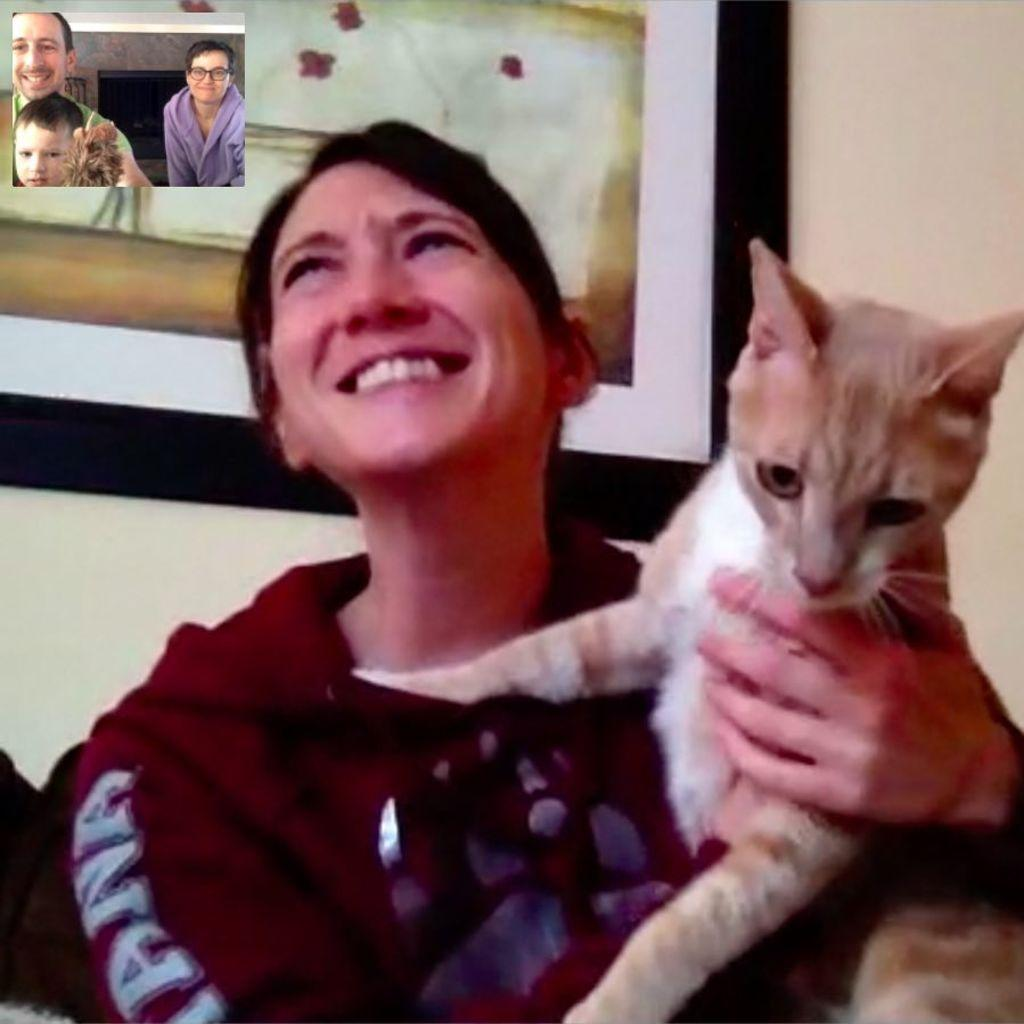What is the woman in the image holding? The woman is holding a cat. Can you describe the other people in the image? There are other people in the image, but their specific actions or features are not mentioned in the provided facts. How many people are wearing glasses in the image? One person in the image is wearing glasses (specs). How many kittens are playing with the cat in the image? There are no kittens present in the image; the woman is holding a single cat. What is the rate of the cat's heartbeat in the image? The provided facts do not include any information about the cat's heartbeat, so it cannot be determined from the image. 